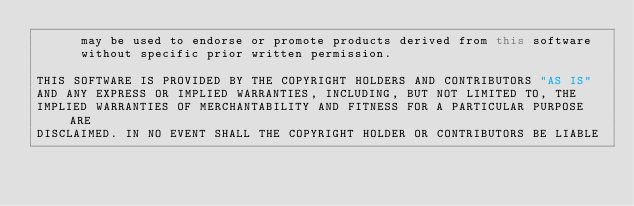Convert code to text. <code><loc_0><loc_0><loc_500><loc_500><_Java_>      may be used to endorse or promote products derived from this software
      without specific prior written permission.

THIS SOFTWARE IS PROVIDED BY THE COPYRIGHT HOLDERS AND CONTRIBUTORS "AS IS"
AND ANY EXPRESS OR IMPLIED WARRANTIES, INCLUDING, BUT NOT LIMITED TO, THE
IMPLIED WARRANTIES OF MERCHANTABILITY AND FITNESS FOR A PARTICULAR PURPOSE ARE
DISCLAIMED. IN NO EVENT SHALL THE COPYRIGHT HOLDER OR CONTRIBUTORS BE LIABLE</code> 